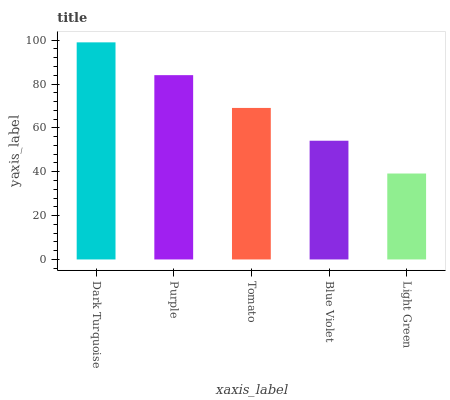Is Light Green the minimum?
Answer yes or no. Yes. Is Dark Turquoise the maximum?
Answer yes or no. Yes. Is Purple the minimum?
Answer yes or no. No. Is Purple the maximum?
Answer yes or no. No. Is Dark Turquoise greater than Purple?
Answer yes or no. Yes. Is Purple less than Dark Turquoise?
Answer yes or no. Yes. Is Purple greater than Dark Turquoise?
Answer yes or no. No. Is Dark Turquoise less than Purple?
Answer yes or no. No. Is Tomato the high median?
Answer yes or no. Yes. Is Tomato the low median?
Answer yes or no. Yes. Is Dark Turquoise the high median?
Answer yes or no. No. Is Light Green the low median?
Answer yes or no. No. 